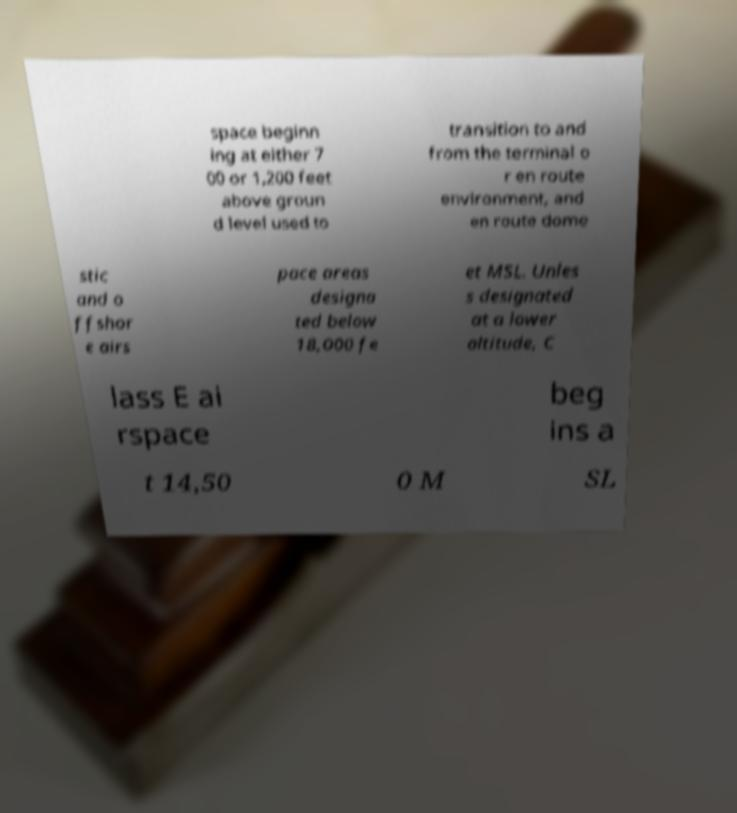Please read and relay the text visible in this image. What does it say? space beginn ing at either 7 00 or 1,200 feet above groun d level used to transition to and from the terminal o r en route environment, and en route dome stic and o ffshor e airs pace areas designa ted below 18,000 fe et MSL. Unles s designated at a lower altitude, C lass E ai rspace beg ins a t 14,50 0 M SL 